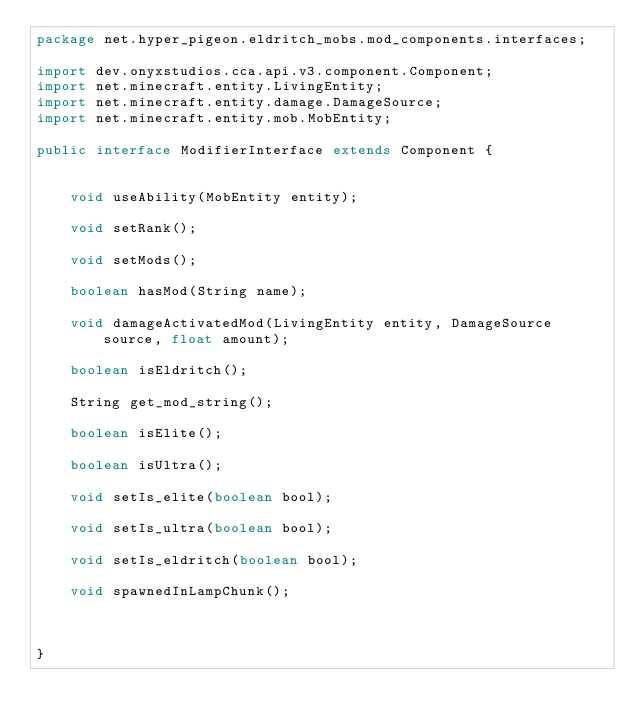Convert code to text. <code><loc_0><loc_0><loc_500><loc_500><_Java_>package net.hyper_pigeon.eldritch_mobs.mod_components.interfaces;

import dev.onyxstudios.cca.api.v3.component.Component;
import net.minecraft.entity.LivingEntity;
import net.minecraft.entity.damage.DamageSource;
import net.minecraft.entity.mob.MobEntity;

public interface ModifierInterface extends Component {


    void useAbility(MobEntity entity);

    void setRank();

    void setMods();

    boolean hasMod(String name);

    void damageActivatedMod(LivingEntity entity, DamageSource source, float amount);

    boolean isEldritch();

    String get_mod_string();

    boolean isElite();

    boolean isUltra();

    void setIs_elite(boolean bool);

    void setIs_ultra(boolean bool);

    void setIs_eldritch(boolean bool);

    void spawnedInLampChunk();



}
</code> 